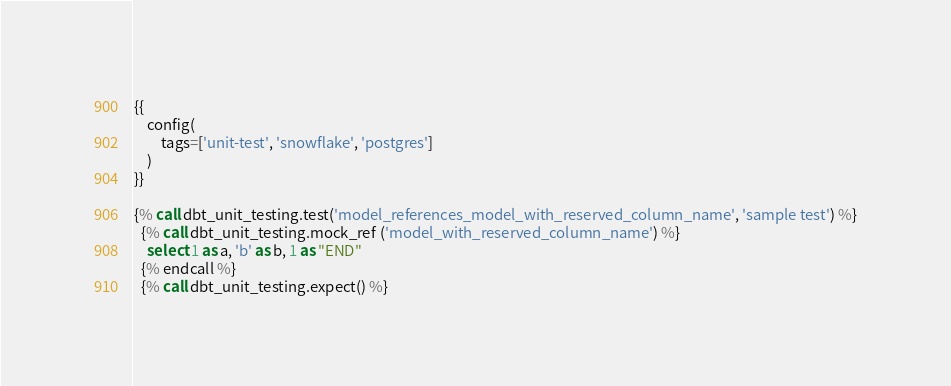Convert code to text. <code><loc_0><loc_0><loc_500><loc_500><_SQL_>{{
    config(
        tags=['unit-test', 'snowflake', 'postgres']
    )
}}

{% call dbt_unit_testing.test('model_references_model_with_reserved_column_name', 'sample test') %}
  {% call dbt_unit_testing.mock_ref ('model_with_reserved_column_name') %}
    select 1 as a, 'b' as b, 1 as "END"
  {% endcall %}
  {% call dbt_unit_testing.expect() %}</code> 